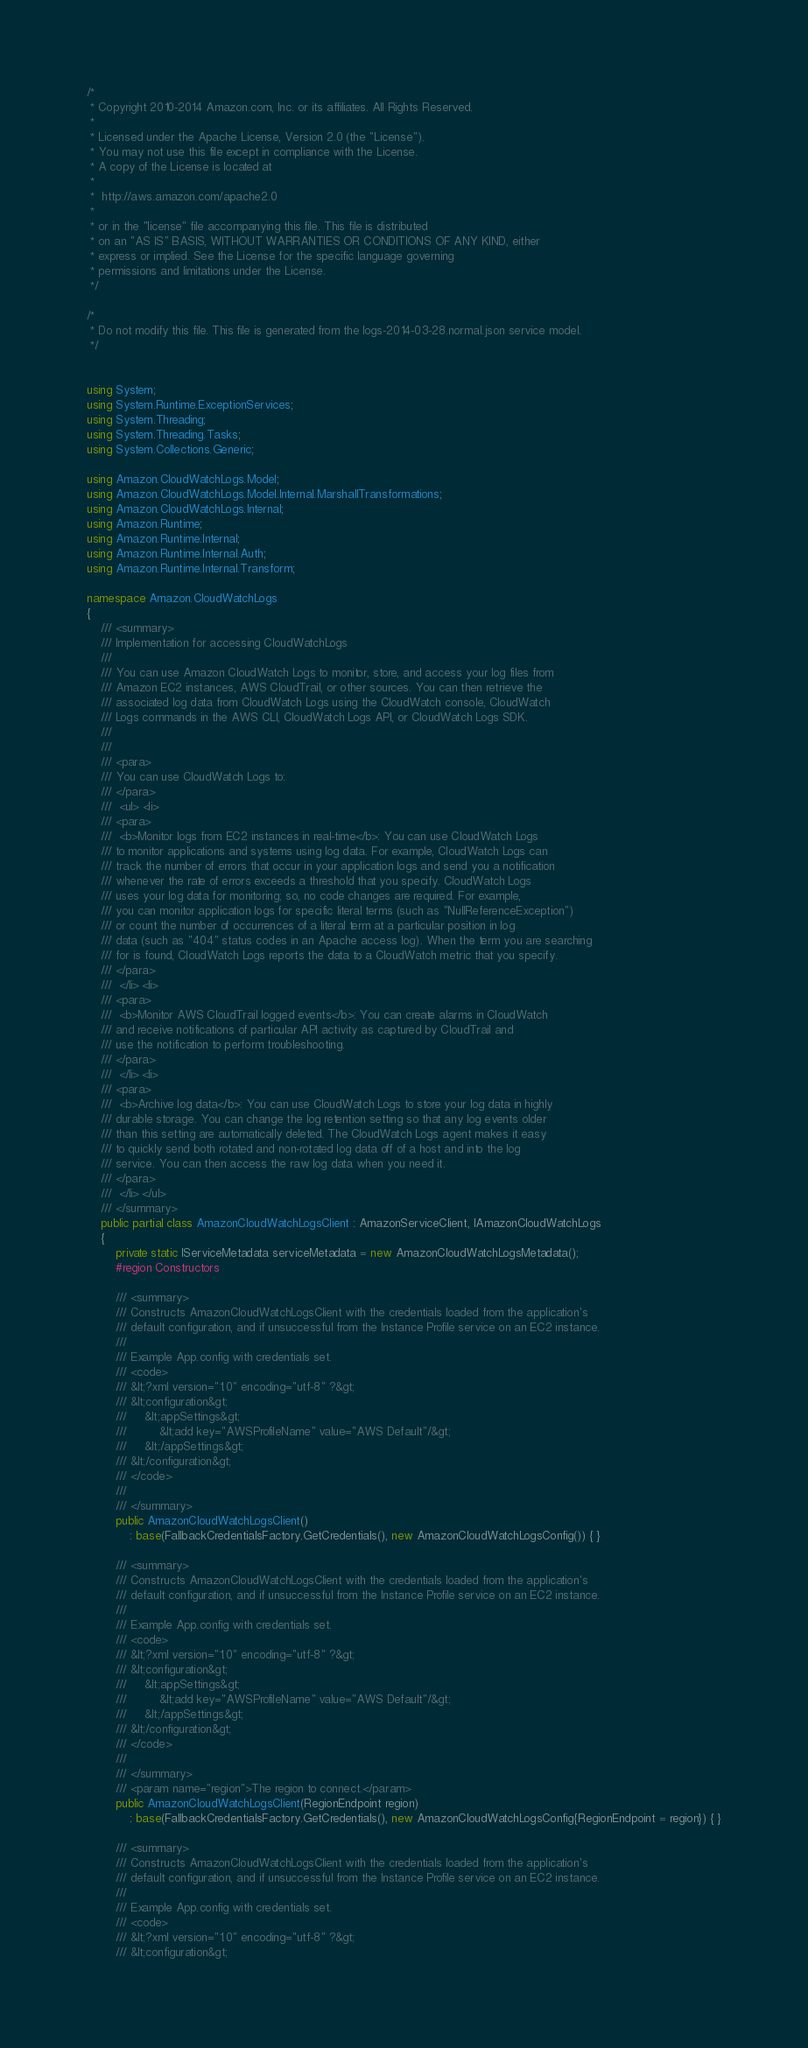Convert code to text. <code><loc_0><loc_0><loc_500><loc_500><_C#_>/*
 * Copyright 2010-2014 Amazon.com, Inc. or its affiliates. All Rights Reserved.
 * 
 * Licensed under the Apache License, Version 2.0 (the "License").
 * You may not use this file except in compliance with the License.
 * A copy of the License is located at
 * 
 *  http://aws.amazon.com/apache2.0
 * 
 * or in the "license" file accompanying this file. This file is distributed
 * on an "AS IS" BASIS, WITHOUT WARRANTIES OR CONDITIONS OF ANY KIND, either
 * express or implied. See the License for the specific language governing
 * permissions and limitations under the License.
 */

/*
 * Do not modify this file. This file is generated from the logs-2014-03-28.normal.json service model.
 */


using System;
using System.Runtime.ExceptionServices;
using System.Threading;
using System.Threading.Tasks;
using System.Collections.Generic;

using Amazon.CloudWatchLogs.Model;
using Amazon.CloudWatchLogs.Model.Internal.MarshallTransformations;
using Amazon.CloudWatchLogs.Internal;
using Amazon.Runtime;
using Amazon.Runtime.Internal;
using Amazon.Runtime.Internal.Auth;
using Amazon.Runtime.Internal.Transform;

namespace Amazon.CloudWatchLogs
{
    /// <summary>
    /// Implementation for accessing CloudWatchLogs
    ///
    /// You can use Amazon CloudWatch Logs to monitor, store, and access your log files from
    /// Amazon EC2 instances, AWS CloudTrail, or other sources. You can then retrieve the
    /// associated log data from CloudWatch Logs using the CloudWatch console, CloudWatch
    /// Logs commands in the AWS CLI, CloudWatch Logs API, or CloudWatch Logs SDK.
    /// 
    ///  
    /// <para>
    /// You can use CloudWatch Logs to:
    /// </para>
    ///  <ul> <li> 
    /// <para>
    ///  <b>Monitor logs from EC2 instances in real-time</b>: You can use CloudWatch Logs
    /// to monitor applications and systems using log data. For example, CloudWatch Logs can
    /// track the number of errors that occur in your application logs and send you a notification
    /// whenever the rate of errors exceeds a threshold that you specify. CloudWatch Logs
    /// uses your log data for monitoring; so, no code changes are required. For example,
    /// you can monitor application logs for specific literal terms (such as "NullReferenceException")
    /// or count the number of occurrences of a literal term at a particular position in log
    /// data (such as "404" status codes in an Apache access log). When the term you are searching
    /// for is found, CloudWatch Logs reports the data to a CloudWatch metric that you specify.
    /// </para>
    ///  </li> <li> 
    /// <para>
    ///  <b>Monitor AWS CloudTrail logged events</b>: You can create alarms in CloudWatch
    /// and receive notifications of particular API activity as captured by CloudTrail and
    /// use the notification to perform troubleshooting.
    /// </para>
    ///  </li> <li> 
    /// <para>
    ///  <b>Archive log data</b>: You can use CloudWatch Logs to store your log data in highly
    /// durable storage. You can change the log retention setting so that any log events older
    /// than this setting are automatically deleted. The CloudWatch Logs agent makes it easy
    /// to quickly send both rotated and non-rotated log data off of a host and into the log
    /// service. You can then access the raw log data when you need it.
    /// </para>
    ///  </li> </ul>
    /// </summary>
    public partial class AmazonCloudWatchLogsClient : AmazonServiceClient, IAmazonCloudWatchLogs
    {
        private static IServiceMetadata serviceMetadata = new AmazonCloudWatchLogsMetadata();
        #region Constructors

        /// <summary>
        /// Constructs AmazonCloudWatchLogsClient with the credentials loaded from the application's
        /// default configuration, and if unsuccessful from the Instance Profile service on an EC2 instance.
        /// 
        /// Example App.config with credentials set. 
        /// <code>
        /// &lt;?xml version="1.0" encoding="utf-8" ?&gt;
        /// &lt;configuration&gt;
        ///     &lt;appSettings&gt;
        ///         &lt;add key="AWSProfileName" value="AWS Default"/&gt;
        ///     &lt;/appSettings&gt;
        /// &lt;/configuration&gt;
        /// </code>
        ///
        /// </summary>
        public AmazonCloudWatchLogsClient()
            : base(FallbackCredentialsFactory.GetCredentials(), new AmazonCloudWatchLogsConfig()) { }

        /// <summary>
        /// Constructs AmazonCloudWatchLogsClient with the credentials loaded from the application's
        /// default configuration, and if unsuccessful from the Instance Profile service on an EC2 instance.
        /// 
        /// Example App.config with credentials set. 
        /// <code>
        /// &lt;?xml version="1.0" encoding="utf-8" ?&gt;
        /// &lt;configuration&gt;
        ///     &lt;appSettings&gt;
        ///         &lt;add key="AWSProfileName" value="AWS Default"/&gt;
        ///     &lt;/appSettings&gt;
        /// &lt;/configuration&gt;
        /// </code>
        ///
        /// </summary>
        /// <param name="region">The region to connect.</param>
        public AmazonCloudWatchLogsClient(RegionEndpoint region)
            : base(FallbackCredentialsFactory.GetCredentials(), new AmazonCloudWatchLogsConfig{RegionEndpoint = region}) { }

        /// <summary>
        /// Constructs AmazonCloudWatchLogsClient with the credentials loaded from the application's
        /// default configuration, and if unsuccessful from the Instance Profile service on an EC2 instance.
        /// 
        /// Example App.config with credentials set. 
        /// <code>
        /// &lt;?xml version="1.0" encoding="utf-8" ?&gt;
        /// &lt;configuration&gt;</code> 